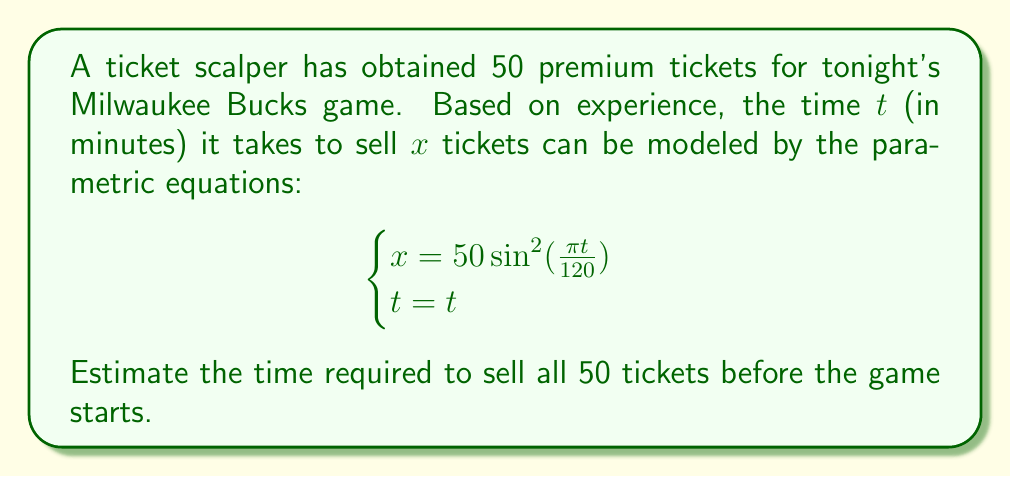Teach me how to tackle this problem. To solve this problem, we need to find the value of $t$ when $x = 50$. Let's approach this step-by-step:

1) We're given the parametric equation for $x$:
   $x = 50\sin^2(\frac{\pi t}{120})$

2) We want to find $t$ when $x = 50$. So, let's set up the equation:
   $50 = 50\sin^2(\frac{\pi t}{120})$

3) Simplify by dividing both sides by 50:
   $1 = \sin^2(\frac{\pi t}{120})$

4) The sine function equals 1 when its argument is $\frac{\pi}{2}$ (or 90 degrees). So:
   $\frac{\pi t}{120} = \frac{\pi}{2}$

5) Multiply both sides by $\frac{120}{\pi}$:
   $t = \frac{120}{2} = 60$

Therefore, it will take 60 minutes, or 1 hour, to sell all 50 tickets.

We can verify this by plugging $t = 60$ back into the original equation:
$x = 50\sin^2(\frac{\pi (60)}{120}) = 50\sin^2(\frac{\pi}{2}) = 50(1) = 50$

This confirms that at $t = 60$ minutes, all 50 tickets will be sold.
Answer: 60 minutes 